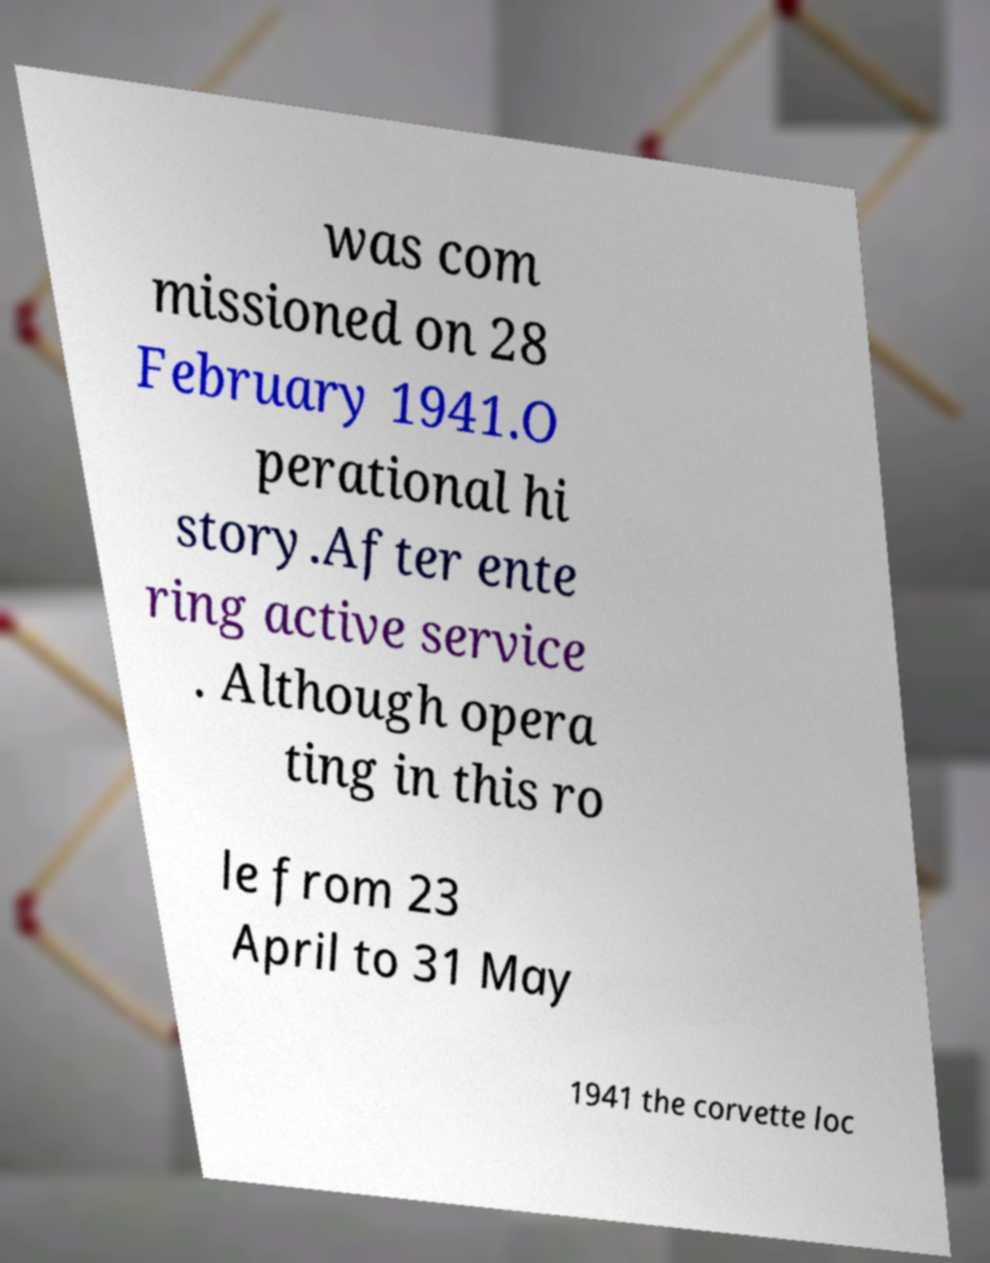Could you extract and type out the text from this image? was com missioned on 28 February 1941.O perational hi story.After ente ring active service . Although opera ting in this ro le from 23 April to 31 May 1941 the corvette loc 